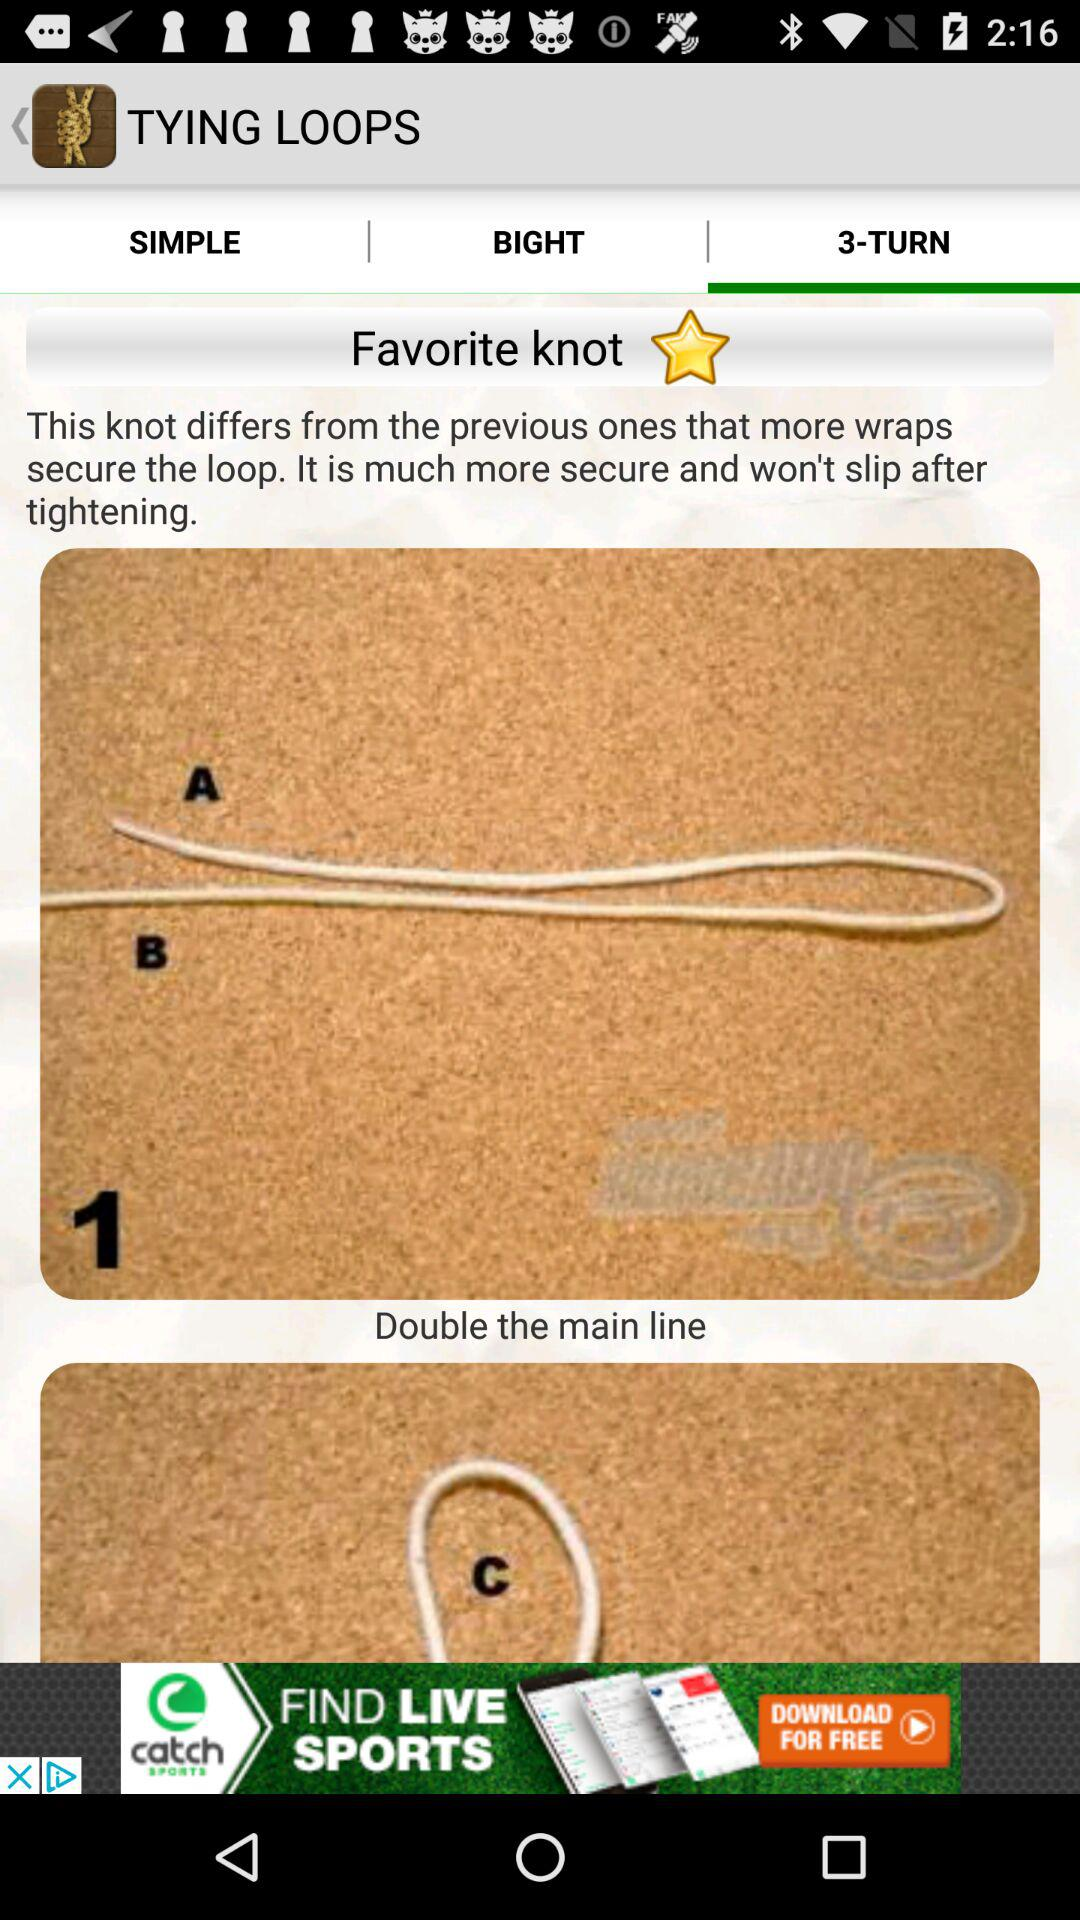What is the name of the application? The name of the application is "TYING LOOPS". 